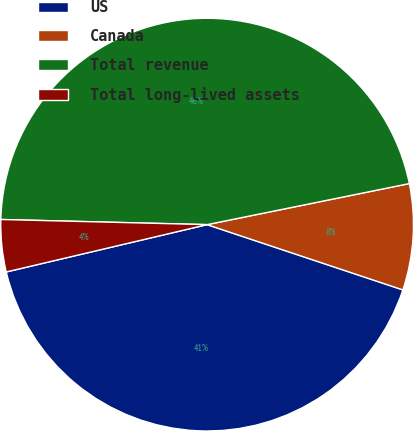<chart> <loc_0><loc_0><loc_500><loc_500><pie_chart><fcel>US<fcel>Canada<fcel>Total revenue<fcel>Total long-lived assets<nl><fcel>41.19%<fcel>8.31%<fcel>46.41%<fcel>4.08%<nl></chart> 